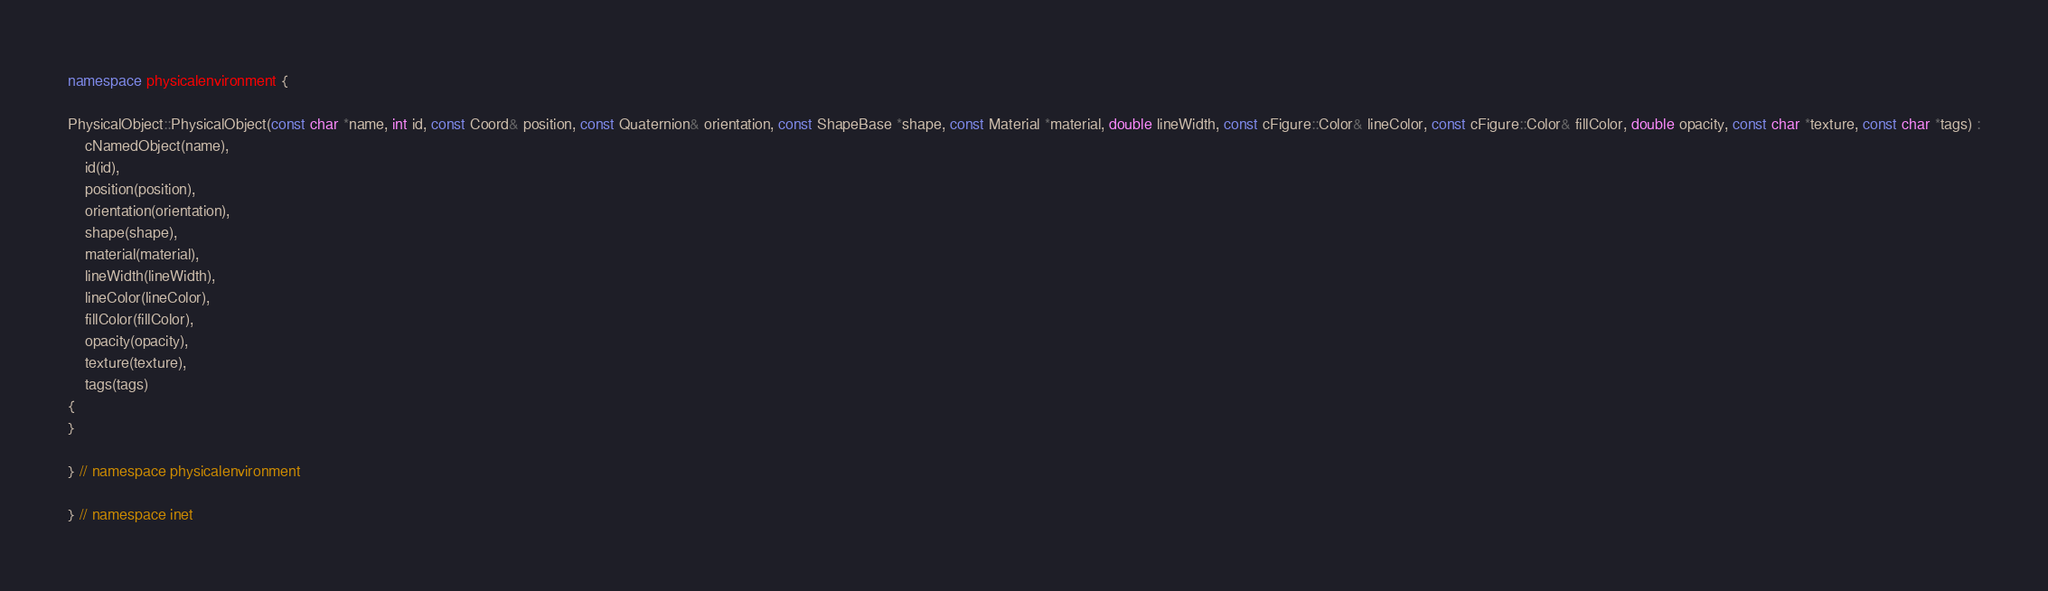<code> <loc_0><loc_0><loc_500><loc_500><_C++_>
namespace physicalenvironment {

PhysicalObject::PhysicalObject(const char *name, int id, const Coord& position, const Quaternion& orientation, const ShapeBase *shape, const Material *material, double lineWidth, const cFigure::Color& lineColor, const cFigure::Color& fillColor, double opacity, const char *texture, const char *tags) :
    cNamedObject(name),
    id(id),
    position(position),
    orientation(orientation),
    shape(shape),
    material(material),
    lineWidth(lineWidth),
    lineColor(lineColor),
    fillColor(fillColor),
    opacity(opacity),
    texture(texture),
    tags(tags)
{
}

} // namespace physicalenvironment

} // namespace inet

</code> 